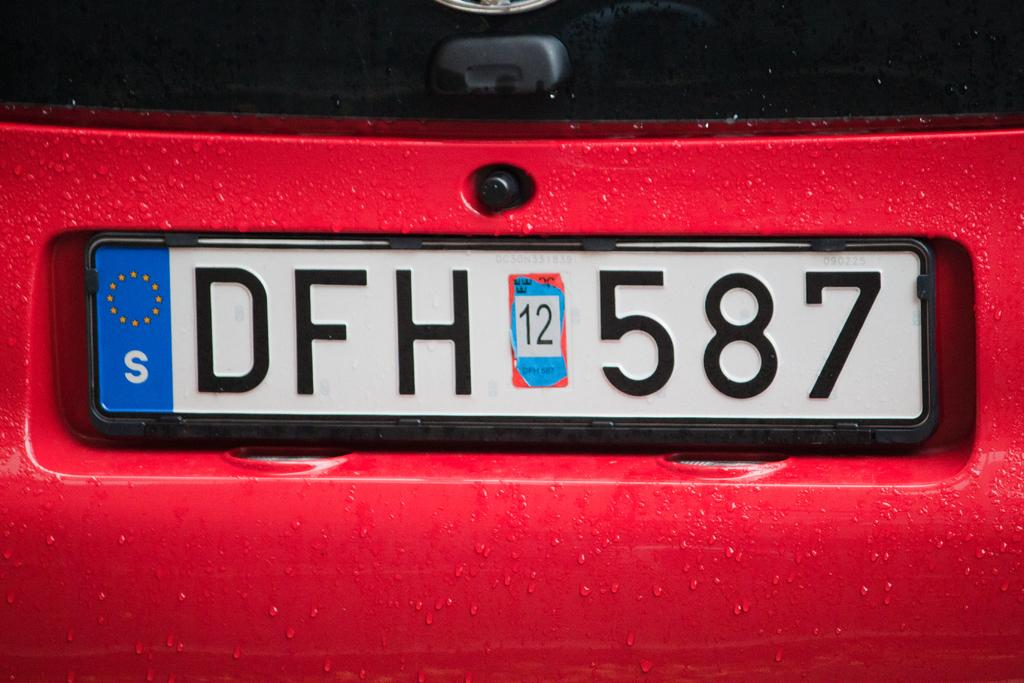Provide a one-sentence caption for the provided image. License plate with the word DFH 12 587 placed on a red car. 